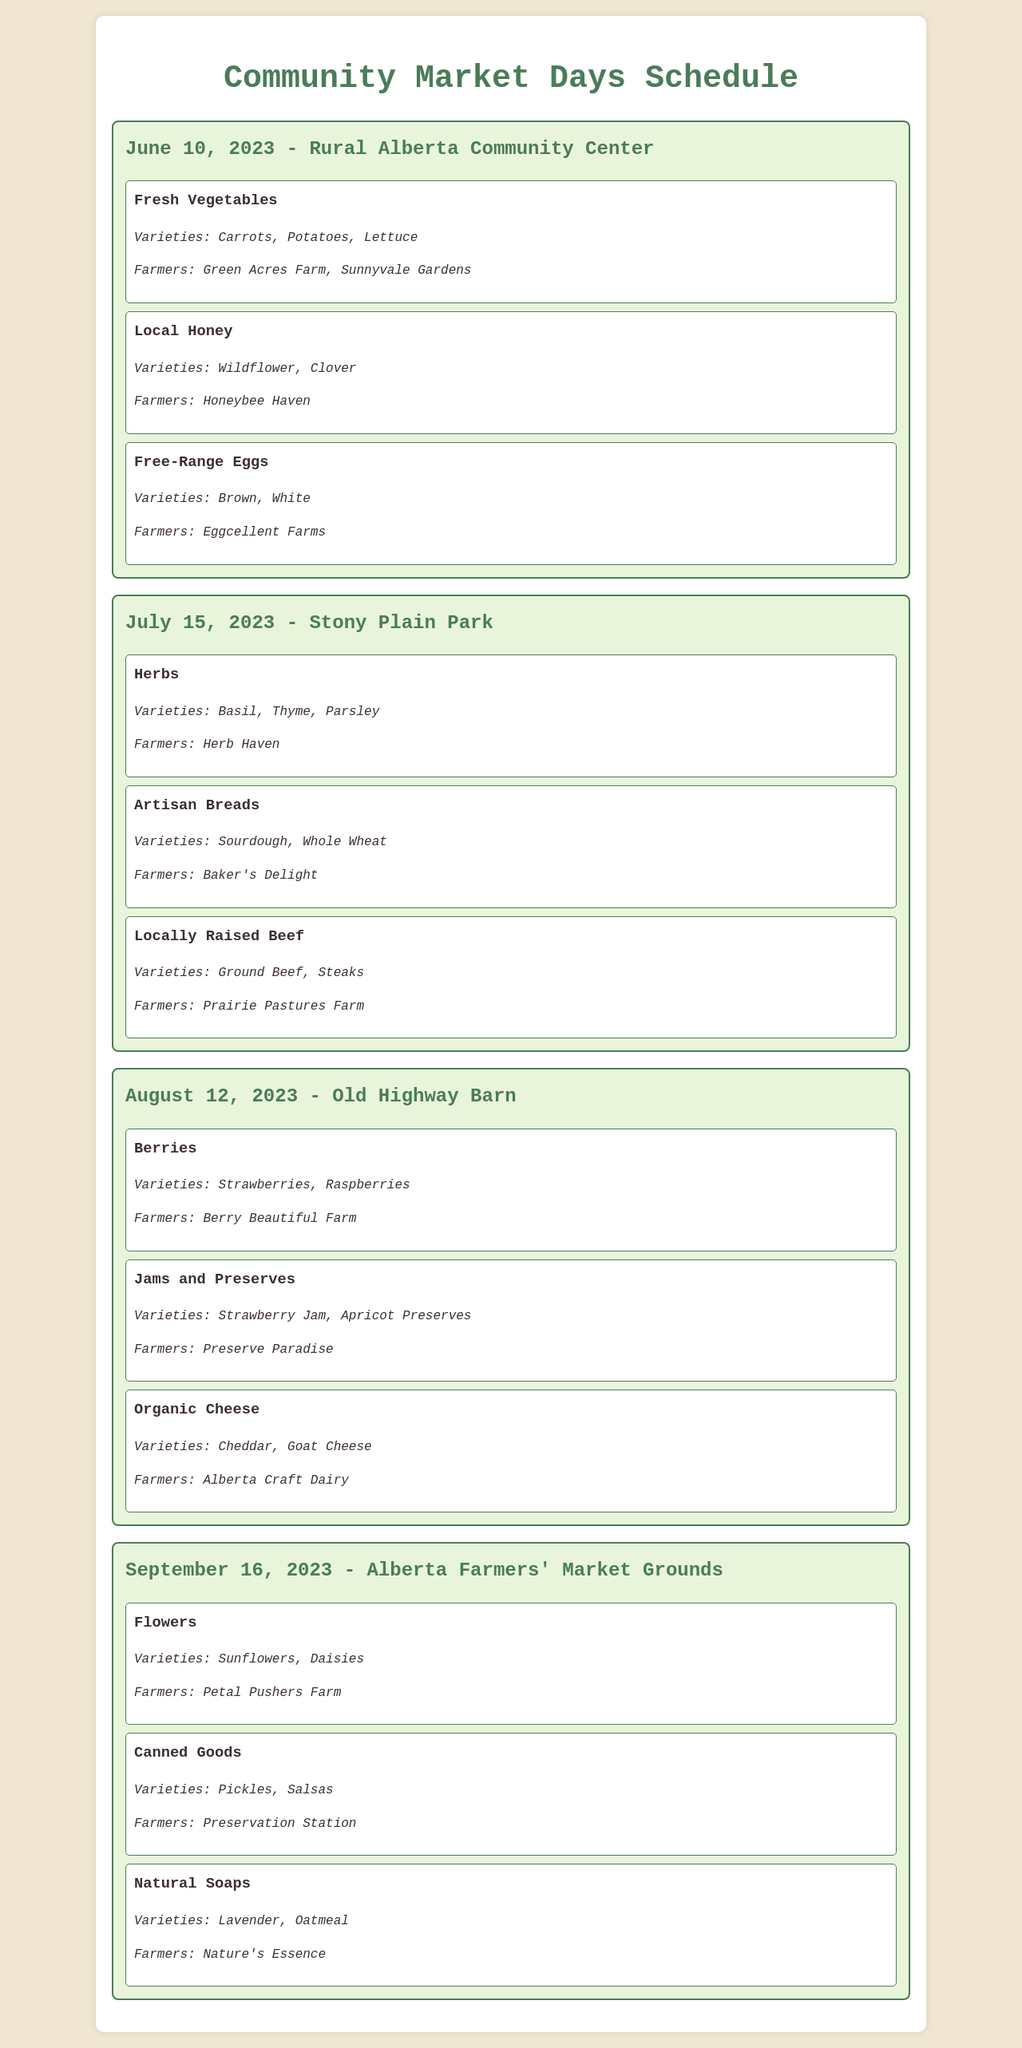What is the date of the first market day? The date of the first market day listed in the document is June 10, 2023.
Answer: June 10, 2023 Where is the July market day held? The location of the July market day is Stony Plain Park, as mentioned in the document.
Answer: Stony Plain Park Which farmer is selling organic cheese? The farmer selling organic cheese is Alberta Craft Dairy, as indicated in the document.
Answer: Alberta Craft Dairy What types of vegetables are available on June 10? Fresh vegetables available on June 10 include carrots, potatoes, and lettuce, according to the document.
Answer: Carrots, Potatoes, Lettuce How many products are listed for sale on August 12? The document lists three products available for sale on August 12, 2023.
Answer: Three Which product has varieties of wildflower and clover? The product with varieties of wildflower and clover is local honey, as per the information in the document.
Answer: Local Honey Which month does the final market day occur? The final market day occurs in September 2023, as listed in the document.
Answer: September What is the name of the market day at Old Highway Barn? The name of the market day at Old Highway Barn is the market day on August 12, 2023.
Answer: August 12, 2023 